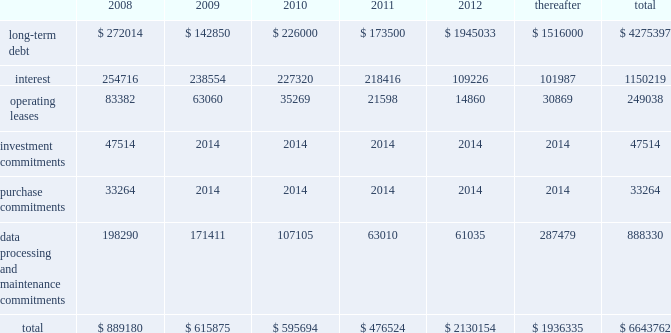Our existing cash flow hedges are highly effective and there is no current impact on earnings due to hedge ineffectiveness .
It is our policy to execute such instruments with credit-worthy banks and not to enter into derivative financial instruments for speculative purposes .
Contractual obligations fis 2019s long-term contractual obligations generally include its long-term debt and operating lease payments on certain of its property and equipment .
The table summarizes fis 2019s significant contractual obligations and commitments as of december 31 , 2007 ( in thousands ) : .
Off-balance sheet arrangements fis does not have any material off-balance sheet arrangements other than operating leases .
Escrow arrangements in conducting our title agency , closing and 1031 exchange services operations , we routinely hold customers 2019 assets in escrow , pending completion of real estate transactions .
Certain of these amounts are maintained in segregated bank accounts and have not been included in the accompanying consolidated balance sheets .
We have a contingent liability relating to proper disposition of these balances , which amounted to $ 1926.8 million at december 31 , 2007 .
As a result of holding these customers 2019 assets in escrow , we have ongoing programs for realizing economic benefits during the year through favorable borrowing and vendor arrangements with various banks .
There were no loans outstanding as of december 31 , 2007 and these balances were invested in short term , high grade investments that minimize the risk to principal .
Recent accounting pronouncements in december 2007 , the fasb issued sfas no .
141 ( revised 2007 ) , business combinations ( 201csfas 141 ( r ) 201d ) , requiring an acquirer in a business combination to recognize the assets acquired , the liabilities assumed , and any noncontrolling interest in the acquiree at their fair values at the acquisition date , with limited exceptions .
The costs of the acquisition and any related restructuring costs will be recognized separately .
Assets and liabilities arising from contingencies in a business combination are to be recognized at their fair value at the acquisition date and adjusted prospectively as new information becomes available .
When the fair value of assets acquired exceeds the fair value of consideration transferred plus any noncontrolling interest in the acquiree , the excess will be recognized as a gain .
Under sfas 141 ( r ) , all business combinations will be accounted for by applying the acquisition method , including combinations among mutual entities and combinations by contract alone .
Sfas 141 ( r ) applies prospectively to business combinations for which the acquisition date is on or after the first annual reporting period beginning on or after december 15 , 2008 , is effective for periods beginning on or after december 15 , 2008 , and will apply to business combinations occurring after the effective date .
Management is currently evaluating the impact of this statement on our statements of financial position and operations .
In december 2007 , the fasb issued sfas no .
160 , noncontrolling interests in consolidated financial statements 2014 an amendment of arb no .
51 ( 201csfas 160 201d ) , requiring noncontrolling interests ( sometimes called minority interests ) to be presented as a component of equity on the balance sheet .
Sfas 160 also requires that the amount of net income attributable to the parent and to the noncontrolling interests be clearly identified and presented on the face of the consolidated statement of income .
This statement eliminates the need to apply purchase .
What portion of the long-term debt is reported as current liabilities as of december 312007? 
Computations: (272014 / 4275397)
Answer: 0.06362. 